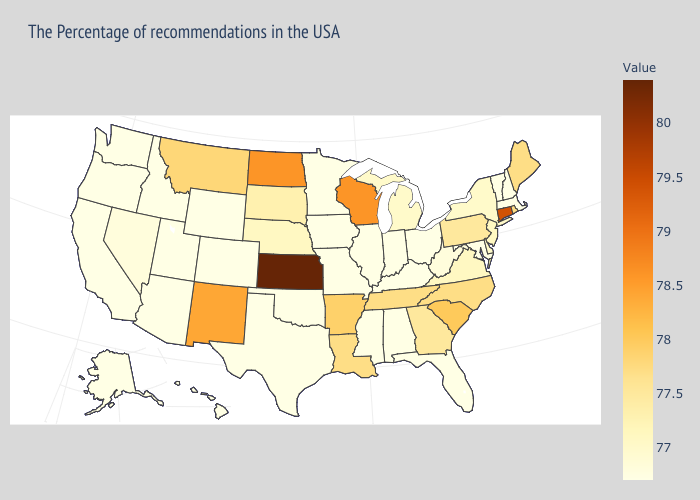Among the states that border Tennessee , which have the lowest value?
Write a very short answer. Kentucky, Alabama, Mississippi, Missouri. Which states have the lowest value in the USA?
Keep it brief. Massachusetts, New Hampshire, Vermont, Maryland, Ohio, Florida, Kentucky, Indiana, Alabama, Illinois, Mississippi, Missouri, Minnesota, Iowa, Oklahoma, Texas, Wyoming, Colorado, Utah, Arizona, Idaho, California, Washington, Oregon, Alaska, Hawaii. Does Pennsylvania have the lowest value in the Northeast?
Write a very short answer. No. Which states have the lowest value in the USA?
Concise answer only. Massachusetts, New Hampshire, Vermont, Maryland, Ohio, Florida, Kentucky, Indiana, Alabama, Illinois, Mississippi, Missouri, Minnesota, Iowa, Oklahoma, Texas, Wyoming, Colorado, Utah, Arizona, Idaho, California, Washington, Oregon, Alaska, Hawaii. 